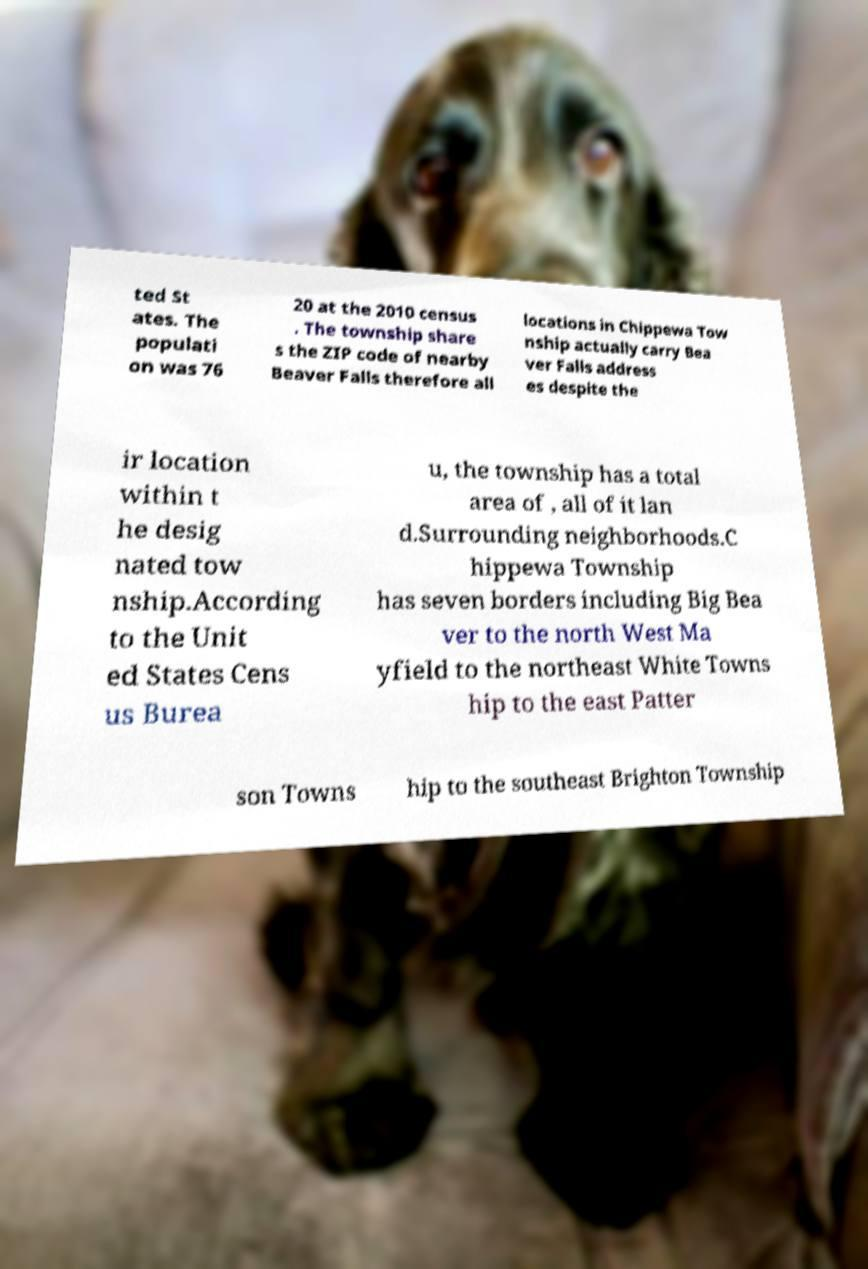I need the written content from this picture converted into text. Can you do that? ted St ates. The populati on was 76 20 at the 2010 census . The township share s the ZIP code of nearby Beaver Falls therefore all locations in Chippewa Tow nship actually carry Bea ver Falls address es despite the ir location within t he desig nated tow nship.According to the Unit ed States Cens us Burea u, the township has a total area of , all of it lan d.Surrounding neighborhoods.C hippewa Township has seven borders including Big Bea ver to the north West Ma yfield to the northeast White Towns hip to the east Patter son Towns hip to the southeast Brighton Township 